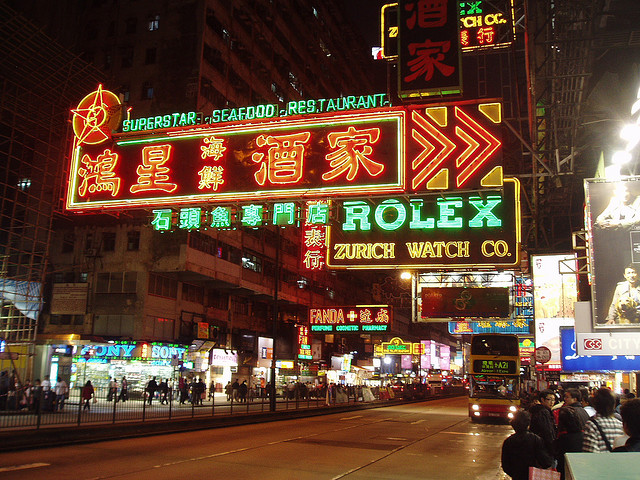Extract all visible text content from this image. ROLEX ZURICH WATCH CO. SEAFOOD SOFT SONY FANDA RES,TAURANT SUPERSTAR 